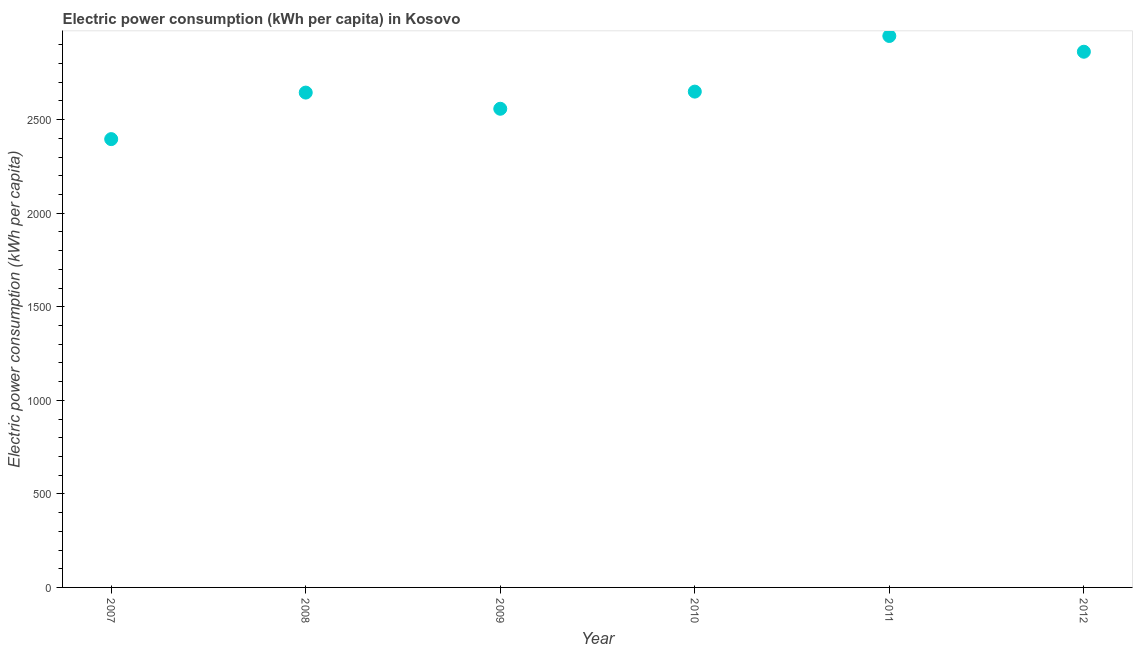What is the electric power consumption in 2008?
Offer a terse response. 2644.53. Across all years, what is the maximum electric power consumption?
Give a very brief answer. 2947.03. Across all years, what is the minimum electric power consumption?
Keep it short and to the point. 2395.86. What is the sum of the electric power consumption?
Offer a very short reply. 1.61e+04. What is the difference between the electric power consumption in 2007 and 2009?
Offer a terse response. -162.22. What is the average electric power consumption per year?
Provide a succinct answer. 2676.34. What is the median electric power consumption?
Ensure brevity in your answer.  2647.11. In how many years, is the electric power consumption greater than 1300 kWh per capita?
Provide a short and direct response. 6. What is the ratio of the electric power consumption in 2009 to that in 2012?
Your response must be concise. 0.89. What is the difference between the highest and the second highest electric power consumption?
Make the answer very short. 84.19. Is the sum of the electric power consumption in 2010 and 2012 greater than the maximum electric power consumption across all years?
Give a very brief answer. Yes. What is the difference between the highest and the lowest electric power consumption?
Ensure brevity in your answer.  551.16. In how many years, is the electric power consumption greater than the average electric power consumption taken over all years?
Provide a succinct answer. 2. Does the electric power consumption monotonically increase over the years?
Your response must be concise. No. How many years are there in the graph?
Ensure brevity in your answer.  6. What is the difference between two consecutive major ticks on the Y-axis?
Provide a succinct answer. 500. Are the values on the major ticks of Y-axis written in scientific E-notation?
Offer a very short reply. No. Does the graph contain grids?
Your answer should be very brief. No. What is the title of the graph?
Make the answer very short. Electric power consumption (kWh per capita) in Kosovo. What is the label or title of the Y-axis?
Keep it short and to the point. Electric power consumption (kWh per capita). What is the Electric power consumption (kWh per capita) in 2007?
Offer a terse response. 2395.86. What is the Electric power consumption (kWh per capita) in 2008?
Your answer should be compact. 2644.53. What is the Electric power consumption (kWh per capita) in 2009?
Give a very brief answer. 2558.08. What is the Electric power consumption (kWh per capita) in 2010?
Offer a very short reply. 2649.69. What is the Electric power consumption (kWh per capita) in 2011?
Your answer should be very brief. 2947.03. What is the Electric power consumption (kWh per capita) in 2012?
Provide a short and direct response. 2862.84. What is the difference between the Electric power consumption (kWh per capita) in 2007 and 2008?
Provide a short and direct response. -248.66. What is the difference between the Electric power consumption (kWh per capita) in 2007 and 2009?
Offer a terse response. -162.22. What is the difference between the Electric power consumption (kWh per capita) in 2007 and 2010?
Make the answer very short. -253.83. What is the difference between the Electric power consumption (kWh per capita) in 2007 and 2011?
Make the answer very short. -551.16. What is the difference between the Electric power consumption (kWh per capita) in 2007 and 2012?
Provide a succinct answer. -466.98. What is the difference between the Electric power consumption (kWh per capita) in 2008 and 2009?
Offer a terse response. 86.44. What is the difference between the Electric power consumption (kWh per capita) in 2008 and 2010?
Your answer should be very brief. -5.16. What is the difference between the Electric power consumption (kWh per capita) in 2008 and 2011?
Offer a terse response. -302.5. What is the difference between the Electric power consumption (kWh per capita) in 2008 and 2012?
Your answer should be compact. -218.31. What is the difference between the Electric power consumption (kWh per capita) in 2009 and 2010?
Ensure brevity in your answer.  -91.6. What is the difference between the Electric power consumption (kWh per capita) in 2009 and 2011?
Your answer should be compact. -388.94. What is the difference between the Electric power consumption (kWh per capita) in 2009 and 2012?
Offer a terse response. -304.76. What is the difference between the Electric power consumption (kWh per capita) in 2010 and 2011?
Make the answer very short. -297.34. What is the difference between the Electric power consumption (kWh per capita) in 2010 and 2012?
Your answer should be compact. -213.15. What is the difference between the Electric power consumption (kWh per capita) in 2011 and 2012?
Make the answer very short. 84.19. What is the ratio of the Electric power consumption (kWh per capita) in 2007 to that in 2008?
Your answer should be very brief. 0.91. What is the ratio of the Electric power consumption (kWh per capita) in 2007 to that in 2009?
Make the answer very short. 0.94. What is the ratio of the Electric power consumption (kWh per capita) in 2007 to that in 2010?
Your answer should be compact. 0.9. What is the ratio of the Electric power consumption (kWh per capita) in 2007 to that in 2011?
Offer a very short reply. 0.81. What is the ratio of the Electric power consumption (kWh per capita) in 2007 to that in 2012?
Your answer should be compact. 0.84. What is the ratio of the Electric power consumption (kWh per capita) in 2008 to that in 2009?
Give a very brief answer. 1.03. What is the ratio of the Electric power consumption (kWh per capita) in 2008 to that in 2011?
Provide a short and direct response. 0.9. What is the ratio of the Electric power consumption (kWh per capita) in 2008 to that in 2012?
Offer a terse response. 0.92. What is the ratio of the Electric power consumption (kWh per capita) in 2009 to that in 2010?
Your response must be concise. 0.96. What is the ratio of the Electric power consumption (kWh per capita) in 2009 to that in 2011?
Give a very brief answer. 0.87. What is the ratio of the Electric power consumption (kWh per capita) in 2009 to that in 2012?
Offer a very short reply. 0.89. What is the ratio of the Electric power consumption (kWh per capita) in 2010 to that in 2011?
Your answer should be compact. 0.9. What is the ratio of the Electric power consumption (kWh per capita) in 2010 to that in 2012?
Offer a very short reply. 0.93. What is the ratio of the Electric power consumption (kWh per capita) in 2011 to that in 2012?
Keep it short and to the point. 1.03. 